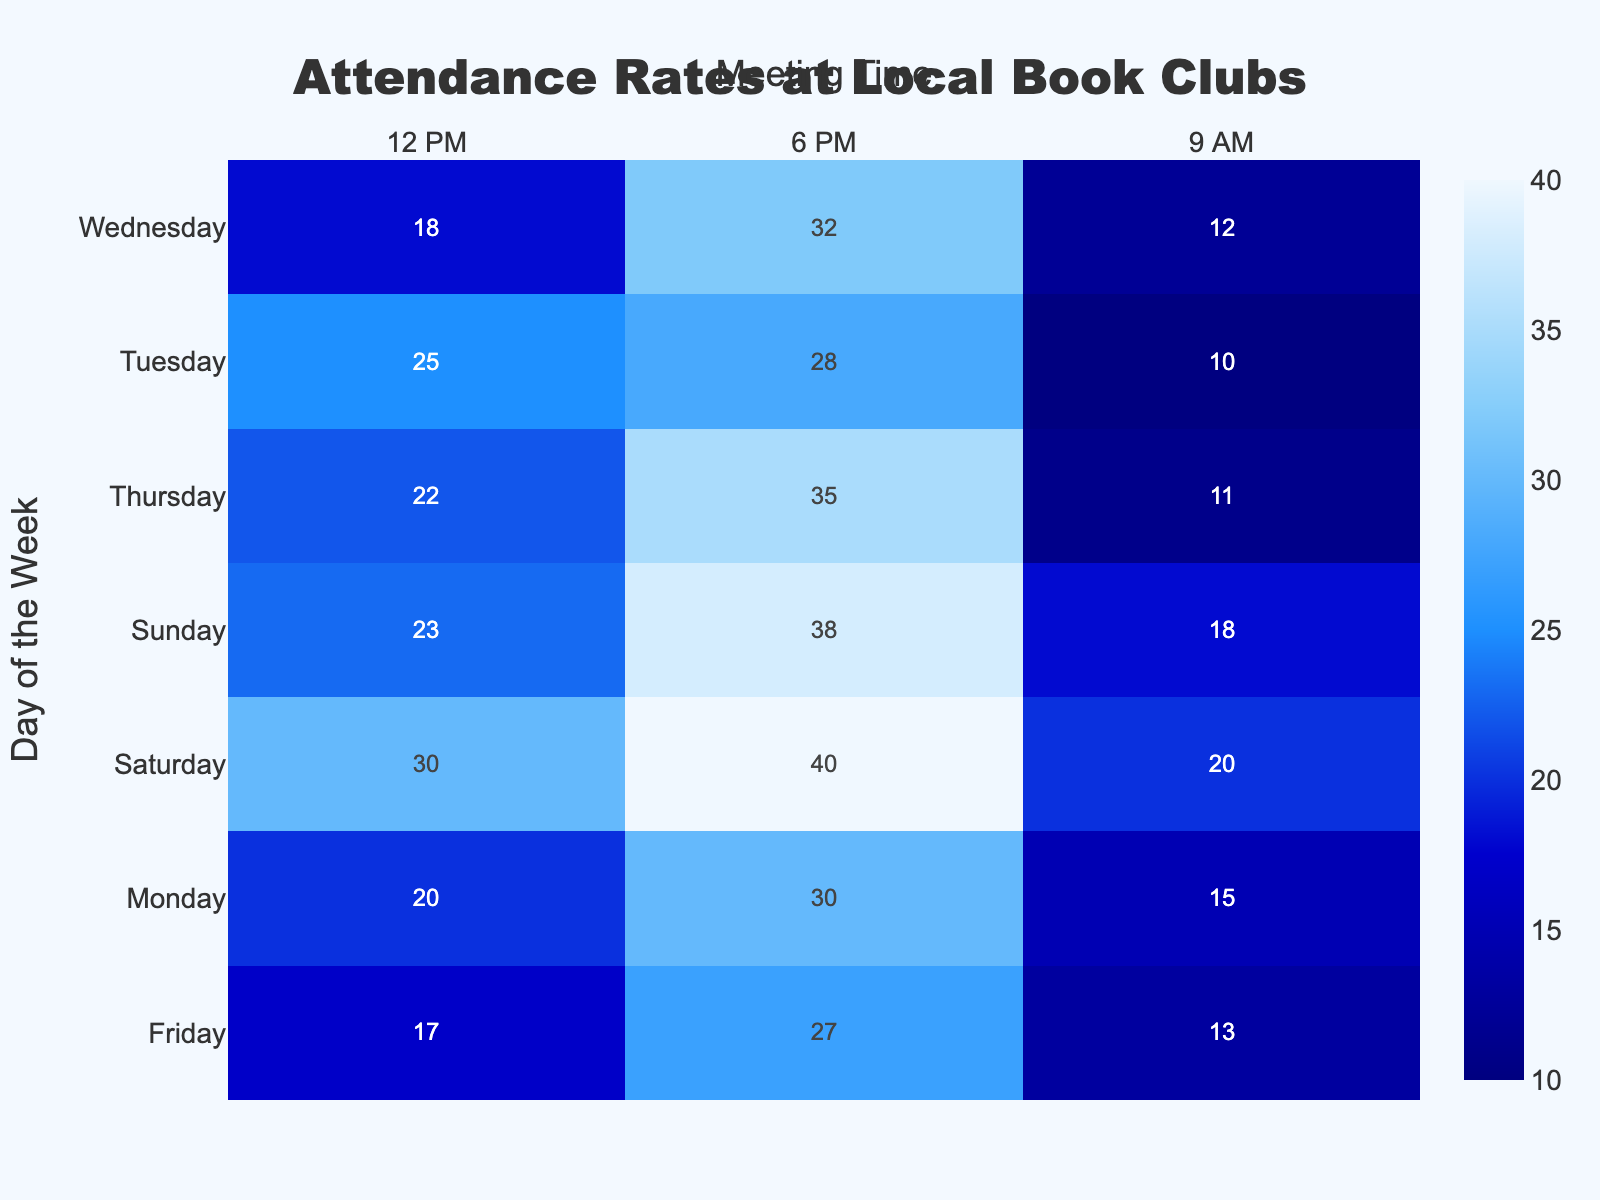What's the title of the heatmap? The title is prominently displayed at the top center of the heatmap, indicating what the visual represents.
Answer: Attendance Rates at Local Book Clubs What are the labels for the x-axis and y-axis? The labels for the x-axis and y-axis are clearly indicated where the axes meet the plot area. The x-axis represents the "Meeting Time" and the y-axis represents the "Day of the Week."
Answer: Meeting Time and Day of the Week What day and time show the highest book club attendance? By looking at the data values in the heatmap, the darkest shaded cell represents peak attendance. It is the cell where the number is the highest.
Answer: Saturday at 6 PM What day and time have the lowest book club attendance? The lightest shaded cell on the heatmap indicates the lowest attendance. It's where the smallest number is displayed.
Answer: Tuesday at 9 AM What's the average attendance for book club meetings held at 12 PM across all days? To find this, extract the attendance values for 12 PM on all days and calculate their average. (20 + 25 + 18 + 22 + 17 + 30 + 23) / 7 = approximately 22.14
Answer: 22.14 Compare the attendance on weekdays vs. weekends at 6 PM. Which has higher average attendance? Weekdays are Monday to Friday: (30 + 28 + 32 + 35 + 27) / 5 = 30.4. Weekends are Saturday and Sunday: (40 + 38) / 2 = 39. The average attendance during weekends at 6 PM is higher.
Answer: Weekends What is the total attendance for book club meetings held on Sundays? Sum the attendance values for each time slot on Sunday: 18 + 23 + 38 = 79.
Answer: 79 Which meeting time shows the most variability in attendance throughout the week? By comparing the range of values across each time slot, we find that 6 PM has a wider variation in attendance numbers from the minimum to the maximum.
Answer: 6 PM How does the Wednesday 6 PM attendance compare to Tuesday 6 PM attendance? The attendance on Wednesday at 6 PM is 32, while on Tuesday at the same time it is 28. Wednesday has a higher attendance.
Answer: Wednesday What is the attendance difference between Saturday 12 PM and Friday 12 PM? Subtract the attendance value for Friday 12 PM from Saturday 12 PM: 30 - 17 = 13.
Answer: 13 